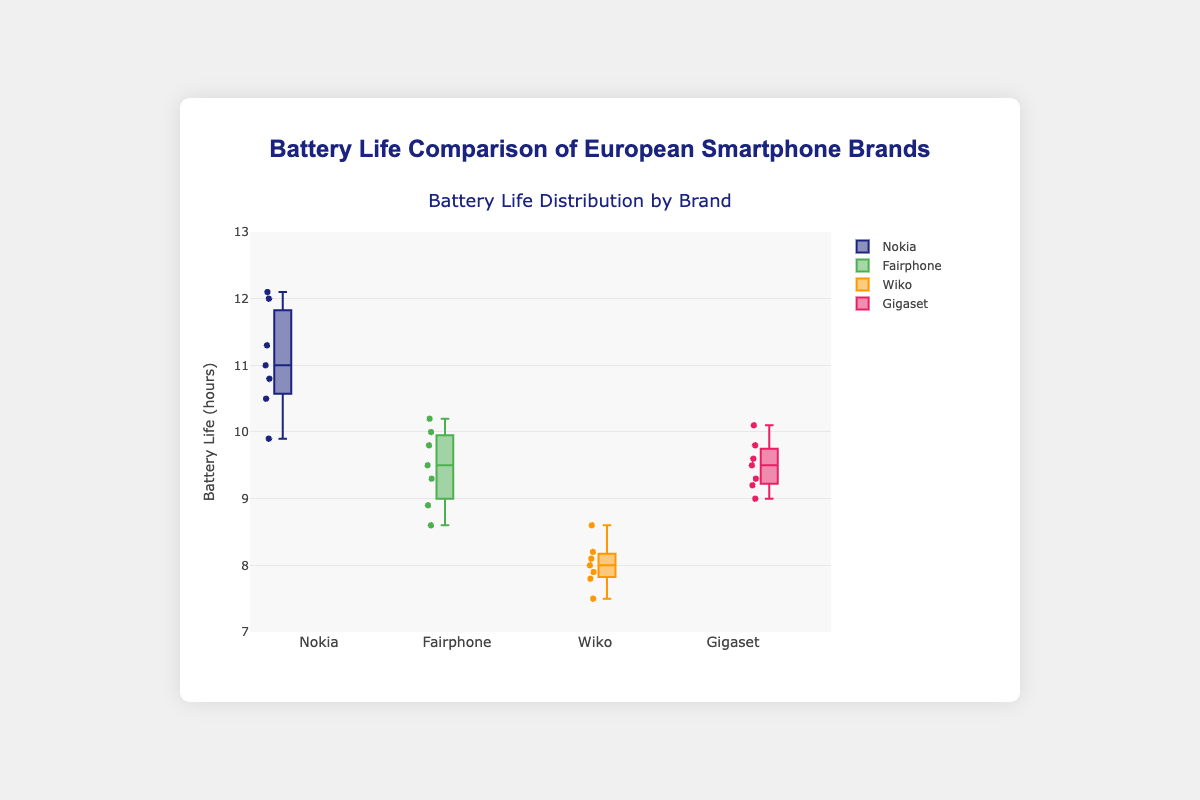What is the title of the figure? The title of the figure is specified at the top of the chart. It reads "Battery Life Comparison of European Smartphone Brands".
Answer: Battery Life Comparison of European Smartphone Brands What is the range of the y-axis? The range of the y-axis is marked by the lowest and highest tick values on the axis. It ranges from 7 to 13 hours.
Answer: 7 to 13 hours Which brand has the highest median battery life? The median battery life for each brand is indicated by the line inside each box. Nokia has the highest median battery life, indicated by the higher position in the box plot.
Answer: Nokia How many data points are there for each brand? Each brand has a specific number of data points marked by small dots around the box plot. Each brand has 7 data points.
Answer: 7 What color represents the Wiko brand? The color representing each brand is shown in the box plot. Wiko is represented by the color orange.
Answer: Orange Which brand has the widest range in battery life? The range can be determined by the length of the box and the whiskers. Nokia has the widest range in battery life.
Answer: Nokia What is the median battery life of Fairphone? The median value is the line inside the box for the Fairphone brand. It is at 9.5 hours.
Answer: 9.5 hours Which two brands have median battery lives closest to each other? The median values are the middle line in the boxes. Fairphone and Gigaset have medians that are very close to each other.
Answer: Fairphone and Gigaset What is the lower quartile value for the Gigaset brand? The lower quartile is the bottom edge of the box for the Gigaset brand. It is at 9.2 hours.
Answer: 9.2 hours Which brand has the smallest interquartile range (IQR)? The IQR can be determined by the distance between the top and bottom edges of the box. Wiko has the smallest IQR.
Answer: Wiko 